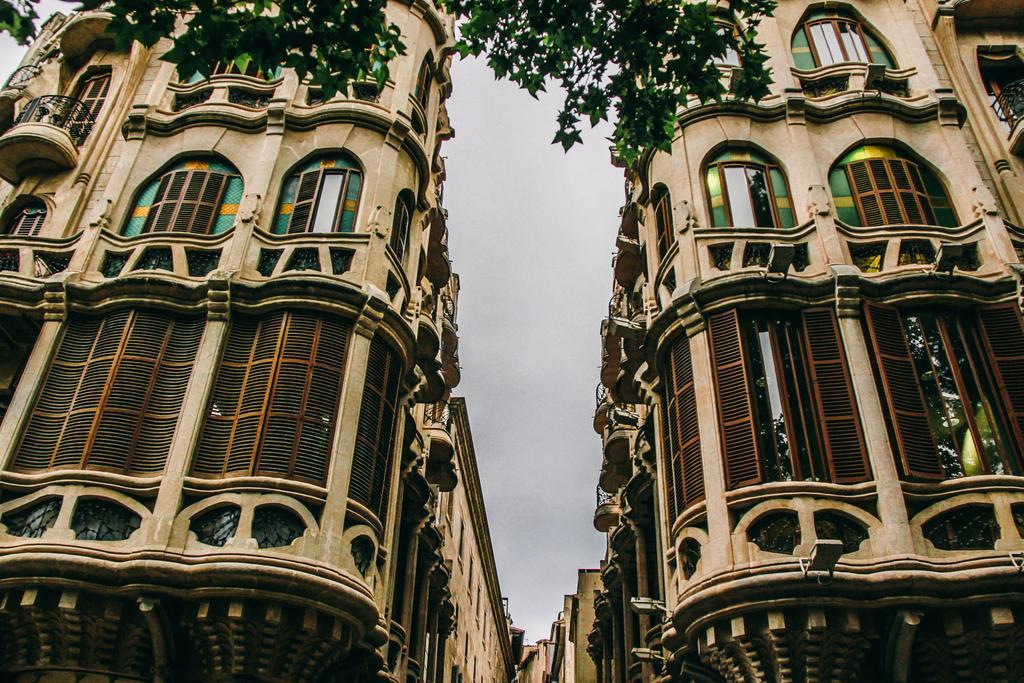Can you describe this image briefly? In this image, we can see buildings, lights, windows and we can see trees. At the top, there is sky. 